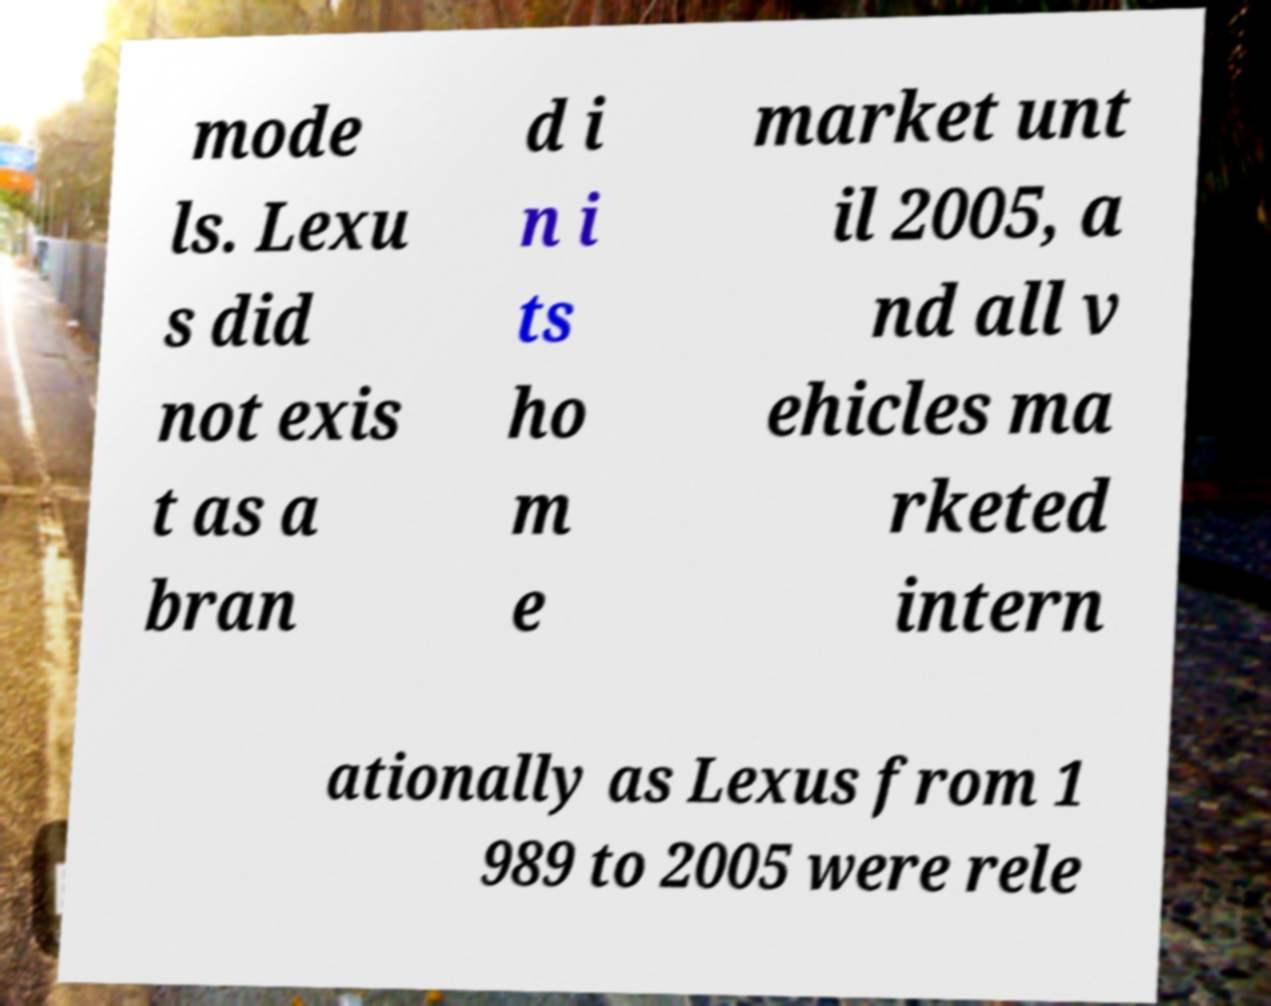Can you accurately transcribe the text from the provided image for me? mode ls. Lexu s did not exis t as a bran d i n i ts ho m e market unt il 2005, a nd all v ehicles ma rketed intern ationally as Lexus from 1 989 to 2005 were rele 